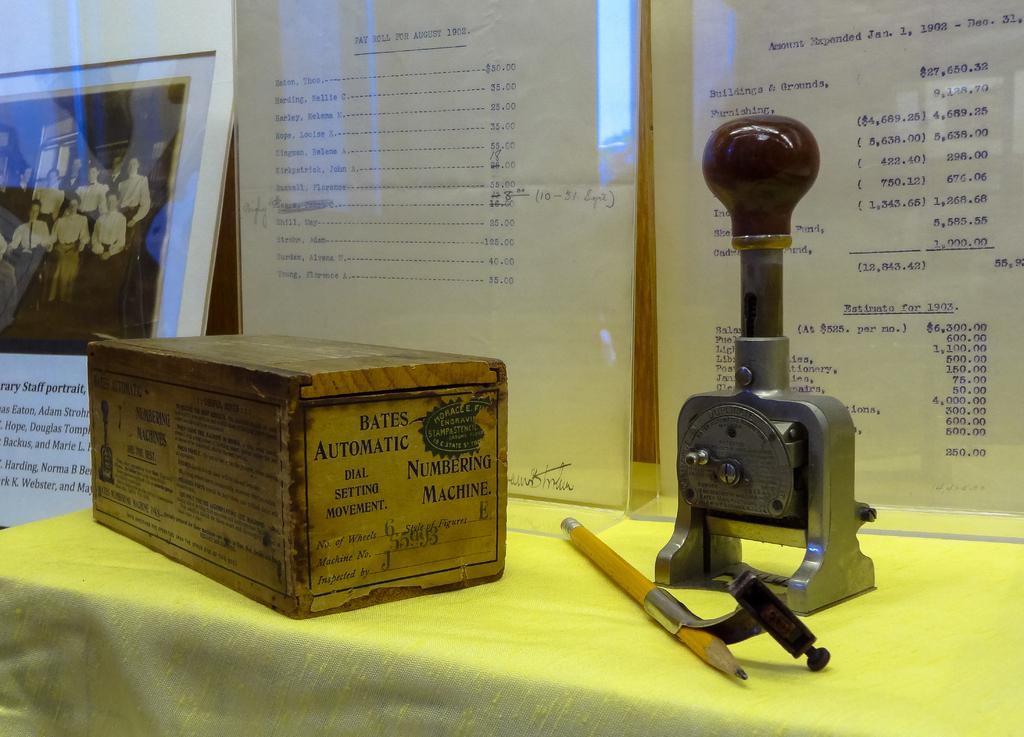What piece of furniture is present in the image? There is a table in the image. What items can be seen on the table? There are boxes, a stamp board, and a pencil on the table. What is the purpose of the display board in the image? The display board has notes on it, suggesting it is used for organizing or displaying information. What type of decorative item is present in the image? There is a photo frame in the image. Can you tell me how many arguments are taking place in the image? There are no arguments present in the image. What type of powder is visible on the table in the image? There is no powder visible on the table in the image. 